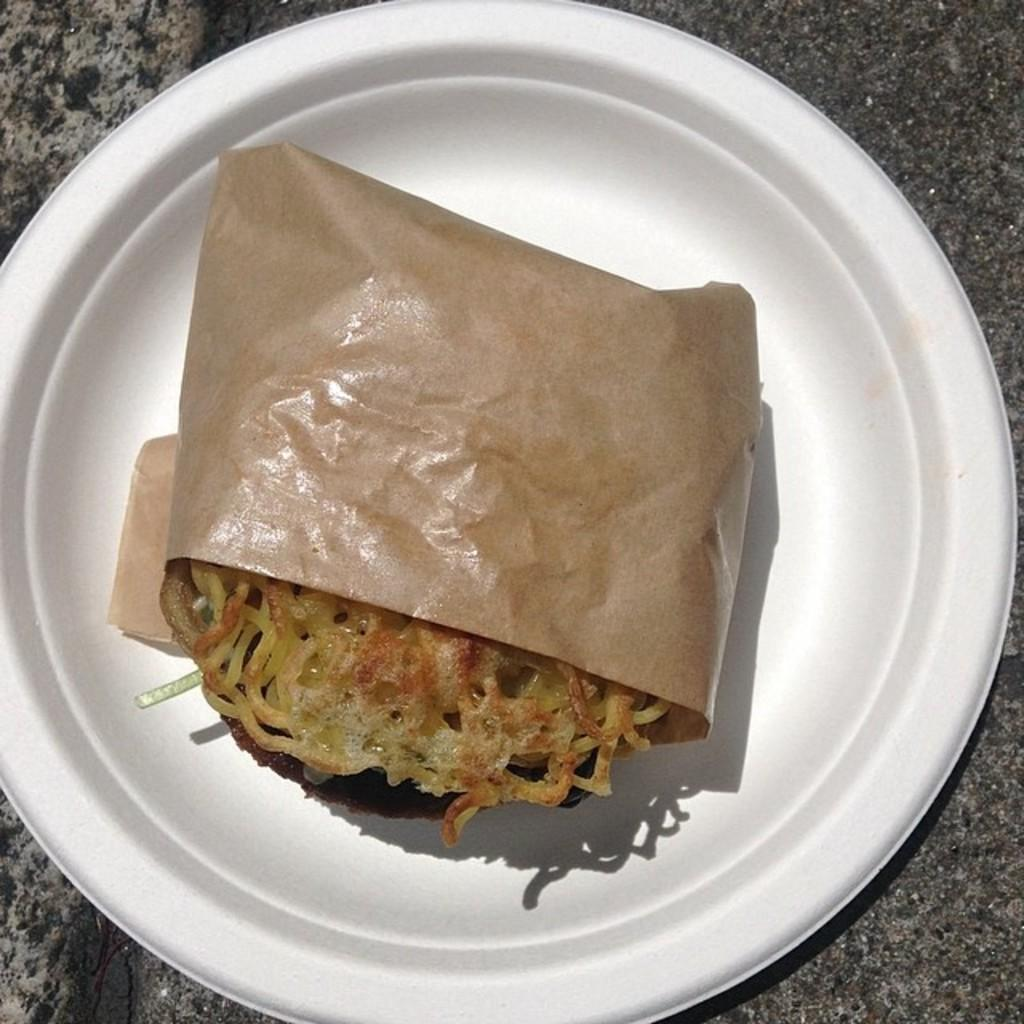What is the main subject of the image? There is a food item in the image. How is the food item presented? The food item is on a white plate. Is there any additional wrapping or covering on the food item? Yes, the food item is wrapped in brown paper. What type of government is depicted in the image? There is no depiction of a government in the image; it features a food item wrapped in brown paper and placed on a white plate. Can you tell me how many fans are visible in the image? There are no fans present in the image. 